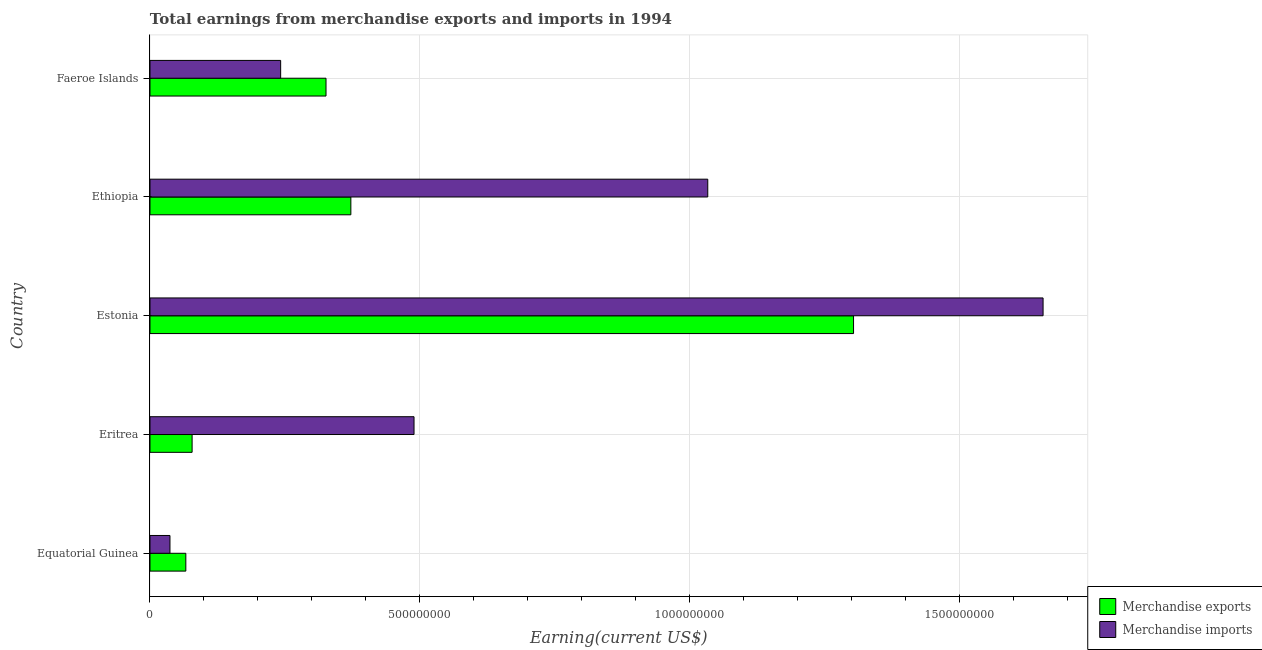How many different coloured bars are there?
Give a very brief answer. 2. How many groups of bars are there?
Your answer should be compact. 5. Are the number of bars per tick equal to the number of legend labels?
Your answer should be very brief. Yes. Are the number of bars on each tick of the Y-axis equal?
Ensure brevity in your answer.  Yes. How many bars are there on the 2nd tick from the top?
Give a very brief answer. 2. What is the label of the 4th group of bars from the top?
Keep it short and to the point. Eritrea. In how many cases, is the number of bars for a given country not equal to the number of legend labels?
Your answer should be compact. 0. What is the earnings from merchandise exports in Eritrea?
Keep it short and to the point. 7.80e+07. Across all countries, what is the maximum earnings from merchandise imports?
Offer a very short reply. 1.65e+09. Across all countries, what is the minimum earnings from merchandise imports?
Offer a very short reply. 3.70e+07. In which country was the earnings from merchandise exports maximum?
Your answer should be very brief. Estonia. In which country was the earnings from merchandise imports minimum?
Provide a short and direct response. Equatorial Guinea. What is the total earnings from merchandise imports in the graph?
Ensure brevity in your answer.  3.46e+09. What is the difference between the earnings from merchandise exports in Equatorial Guinea and that in Faeroe Islands?
Provide a short and direct response. -2.60e+08. What is the difference between the earnings from merchandise exports in Eritrea and the earnings from merchandise imports in Ethiopia?
Offer a terse response. -9.55e+08. What is the average earnings from merchandise exports per country?
Offer a very short reply. 4.29e+08. What is the difference between the earnings from merchandise exports and earnings from merchandise imports in Faeroe Islands?
Your answer should be very brief. 8.40e+07. In how many countries, is the earnings from merchandise imports greater than 1100000000 US$?
Keep it short and to the point. 1. What is the ratio of the earnings from merchandise imports in Estonia to that in Ethiopia?
Keep it short and to the point. 1.6. Is the difference between the earnings from merchandise exports in Estonia and Ethiopia greater than the difference between the earnings from merchandise imports in Estonia and Ethiopia?
Your response must be concise. Yes. What is the difference between the highest and the second highest earnings from merchandise imports?
Offer a very short reply. 6.21e+08. What is the difference between the highest and the lowest earnings from merchandise imports?
Ensure brevity in your answer.  1.62e+09. Is the sum of the earnings from merchandise exports in Eritrea and Ethiopia greater than the maximum earnings from merchandise imports across all countries?
Your answer should be very brief. No. What does the 2nd bar from the bottom in Eritrea represents?
Offer a terse response. Merchandise imports. Are all the bars in the graph horizontal?
Provide a short and direct response. Yes. Are the values on the major ticks of X-axis written in scientific E-notation?
Keep it short and to the point. No. Where does the legend appear in the graph?
Your answer should be compact. Bottom right. How are the legend labels stacked?
Your answer should be compact. Vertical. What is the title of the graph?
Your answer should be compact. Total earnings from merchandise exports and imports in 1994. What is the label or title of the X-axis?
Offer a very short reply. Earning(current US$). What is the label or title of the Y-axis?
Provide a succinct answer. Country. What is the Earning(current US$) of Merchandise exports in Equatorial Guinea?
Offer a very short reply. 6.64e+07. What is the Earning(current US$) in Merchandise imports in Equatorial Guinea?
Provide a short and direct response. 3.70e+07. What is the Earning(current US$) in Merchandise exports in Eritrea?
Your answer should be very brief. 7.80e+07. What is the Earning(current US$) of Merchandise imports in Eritrea?
Give a very brief answer. 4.89e+08. What is the Earning(current US$) of Merchandise exports in Estonia?
Give a very brief answer. 1.30e+09. What is the Earning(current US$) in Merchandise imports in Estonia?
Make the answer very short. 1.65e+09. What is the Earning(current US$) in Merchandise exports in Ethiopia?
Your answer should be very brief. 3.72e+08. What is the Earning(current US$) in Merchandise imports in Ethiopia?
Your answer should be compact. 1.03e+09. What is the Earning(current US$) of Merchandise exports in Faeroe Islands?
Offer a very short reply. 3.26e+08. What is the Earning(current US$) of Merchandise imports in Faeroe Islands?
Provide a short and direct response. 2.42e+08. Across all countries, what is the maximum Earning(current US$) of Merchandise exports?
Your response must be concise. 1.30e+09. Across all countries, what is the maximum Earning(current US$) in Merchandise imports?
Give a very brief answer. 1.65e+09. Across all countries, what is the minimum Earning(current US$) of Merchandise exports?
Keep it short and to the point. 6.64e+07. Across all countries, what is the minimum Earning(current US$) of Merchandise imports?
Ensure brevity in your answer.  3.70e+07. What is the total Earning(current US$) in Merchandise exports in the graph?
Offer a terse response. 2.15e+09. What is the total Earning(current US$) of Merchandise imports in the graph?
Ensure brevity in your answer.  3.46e+09. What is the difference between the Earning(current US$) of Merchandise exports in Equatorial Guinea and that in Eritrea?
Make the answer very short. -1.16e+07. What is the difference between the Earning(current US$) of Merchandise imports in Equatorial Guinea and that in Eritrea?
Keep it short and to the point. -4.52e+08. What is the difference between the Earning(current US$) of Merchandise exports in Equatorial Guinea and that in Estonia?
Offer a terse response. -1.24e+09. What is the difference between the Earning(current US$) in Merchandise imports in Equatorial Guinea and that in Estonia?
Your answer should be very brief. -1.62e+09. What is the difference between the Earning(current US$) in Merchandise exports in Equatorial Guinea and that in Ethiopia?
Make the answer very short. -3.06e+08. What is the difference between the Earning(current US$) in Merchandise imports in Equatorial Guinea and that in Ethiopia?
Provide a short and direct response. -9.96e+08. What is the difference between the Earning(current US$) of Merchandise exports in Equatorial Guinea and that in Faeroe Islands?
Provide a succinct answer. -2.60e+08. What is the difference between the Earning(current US$) in Merchandise imports in Equatorial Guinea and that in Faeroe Islands?
Offer a very short reply. -2.05e+08. What is the difference between the Earning(current US$) in Merchandise exports in Eritrea and that in Estonia?
Make the answer very short. -1.22e+09. What is the difference between the Earning(current US$) of Merchandise imports in Eritrea and that in Estonia?
Ensure brevity in your answer.  -1.16e+09. What is the difference between the Earning(current US$) in Merchandise exports in Eritrea and that in Ethiopia?
Make the answer very short. -2.94e+08. What is the difference between the Earning(current US$) of Merchandise imports in Eritrea and that in Ethiopia?
Your answer should be compact. -5.44e+08. What is the difference between the Earning(current US$) in Merchandise exports in Eritrea and that in Faeroe Islands?
Give a very brief answer. -2.48e+08. What is the difference between the Earning(current US$) in Merchandise imports in Eritrea and that in Faeroe Islands?
Give a very brief answer. 2.47e+08. What is the difference between the Earning(current US$) in Merchandise exports in Estonia and that in Ethiopia?
Provide a succinct answer. 9.31e+08. What is the difference between the Earning(current US$) of Merchandise imports in Estonia and that in Ethiopia?
Offer a very short reply. 6.21e+08. What is the difference between the Earning(current US$) of Merchandise exports in Estonia and that in Faeroe Islands?
Provide a succinct answer. 9.77e+08. What is the difference between the Earning(current US$) in Merchandise imports in Estonia and that in Faeroe Islands?
Ensure brevity in your answer.  1.41e+09. What is the difference between the Earning(current US$) of Merchandise exports in Ethiopia and that in Faeroe Islands?
Your response must be concise. 4.60e+07. What is the difference between the Earning(current US$) in Merchandise imports in Ethiopia and that in Faeroe Islands?
Keep it short and to the point. 7.91e+08. What is the difference between the Earning(current US$) of Merchandise exports in Equatorial Guinea and the Earning(current US$) of Merchandise imports in Eritrea?
Provide a succinct answer. -4.23e+08. What is the difference between the Earning(current US$) in Merchandise exports in Equatorial Guinea and the Earning(current US$) in Merchandise imports in Estonia?
Give a very brief answer. -1.59e+09. What is the difference between the Earning(current US$) of Merchandise exports in Equatorial Guinea and the Earning(current US$) of Merchandise imports in Ethiopia?
Your response must be concise. -9.67e+08. What is the difference between the Earning(current US$) in Merchandise exports in Equatorial Guinea and the Earning(current US$) in Merchandise imports in Faeroe Islands?
Offer a terse response. -1.76e+08. What is the difference between the Earning(current US$) in Merchandise exports in Eritrea and the Earning(current US$) in Merchandise imports in Estonia?
Provide a succinct answer. -1.58e+09. What is the difference between the Earning(current US$) of Merchandise exports in Eritrea and the Earning(current US$) of Merchandise imports in Ethiopia?
Provide a succinct answer. -9.55e+08. What is the difference between the Earning(current US$) in Merchandise exports in Eritrea and the Earning(current US$) in Merchandise imports in Faeroe Islands?
Ensure brevity in your answer.  -1.64e+08. What is the difference between the Earning(current US$) of Merchandise exports in Estonia and the Earning(current US$) of Merchandise imports in Ethiopia?
Ensure brevity in your answer.  2.70e+08. What is the difference between the Earning(current US$) of Merchandise exports in Estonia and the Earning(current US$) of Merchandise imports in Faeroe Islands?
Keep it short and to the point. 1.06e+09. What is the difference between the Earning(current US$) in Merchandise exports in Ethiopia and the Earning(current US$) in Merchandise imports in Faeroe Islands?
Your response must be concise. 1.30e+08. What is the average Earning(current US$) of Merchandise exports per country?
Give a very brief answer. 4.29e+08. What is the average Earning(current US$) of Merchandise imports per country?
Make the answer very short. 6.91e+08. What is the difference between the Earning(current US$) of Merchandise exports and Earning(current US$) of Merchandise imports in Equatorial Guinea?
Give a very brief answer. 2.94e+07. What is the difference between the Earning(current US$) of Merchandise exports and Earning(current US$) of Merchandise imports in Eritrea?
Provide a succinct answer. -4.11e+08. What is the difference between the Earning(current US$) in Merchandise exports and Earning(current US$) in Merchandise imports in Estonia?
Give a very brief answer. -3.51e+08. What is the difference between the Earning(current US$) in Merchandise exports and Earning(current US$) in Merchandise imports in Ethiopia?
Your answer should be very brief. -6.61e+08. What is the difference between the Earning(current US$) in Merchandise exports and Earning(current US$) in Merchandise imports in Faeroe Islands?
Offer a terse response. 8.40e+07. What is the ratio of the Earning(current US$) of Merchandise exports in Equatorial Guinea to that in Eritrea?
Provide a succinct answer. 0.85. What is the ratio of the Earning(current US$) of Merchandise imports in Equatorial Guinea to that in Eritrea?
Your answer should be compact. 0.08. What is the ratio of the Earning(current US$) in Merchandise exports in Equatorial Guinea to that in Estonia?
Your answer should be very brief. 0.05. What is the ratio of the Earning(current US$) of Merchandise imports in Equatorial Guinea to that in Estonia?
Offer a very short reply. 0.02. What is the ratio of the Earning(current US$) in Merchandise exports in Equatorial Guinea to that in Ethiopia?
Your answer should be very brief. 0.18. What is the ratio of the Earning(current US$) in Merchandise imports in Equatorial Guinea to that in Ethiopia?
Ensure brevity in your answer.  0.04. What is the ratio of the Earning(current US$) in Merchandise exports in Equatorial Guinea to that in Faeroe Islands?
Offer a very short reply. 0.2. What is the ratio of the Earning(current US$) of Merchandise imports in Equatorial Guinea to that in Faeroe Islands?
Your response must be concise. 0.15. What is the ratio of the Earning(current US$) in Merchandise exports in Eritrea to that in Estonia?
Give a very brief answer. 0.06. What is the ratio of the Earning(current US$) of Merchandise imports in Eritrea to that in Estonia?
Ensure brevity in your answer.  0.3. What is the ratio of the Earning(current US$) in Merchandise exports in Eritrea to that in Ethiopia?
Your answer should be very brief. 0.21. What is the ratio of the Earning(current US$) of Merchandise imports in Eritrea to that in Ethiopia?
Your response must be concise. 0.47. What is the ratio of the Earning(current US$) of Merchandise exports in Eritrea to that in Faeroe Islands?
Your response must be concise. 0.24. What is the ratio of the Earning(current US$) of Merchandise imports in Eritrea to that in Faeroe Islands?
Offer a terse response. 2.02. What is the ratio of the Earning(current US$) in Merchandise exports in Estonia to that in Ethiopia?
Your answer should be very brief. 3.5. What is the ratio of the Earning(current US$) in Merchandise imports in Estonia to that in Ethiopia?
Your answer should be compact. 1.6. What is the ratio of the Earning(current US$) of Merchandise exports in Estonia to that in Faeroe Islands?
Your response must be concise. 4. What is the ratio of the Earning(current US$) in Merchandise imports in Estonia to that in Faeroe Islands?
Provide a succinct answer. 6.83. What is the ratio of the Earning(current US$) of Merchandise exports in Ethiopia to that in Faeroe Islands?
Your answer should be very brief. 1.14. What is the ratio of the Earning(current US$) of Merchandise imports in Ethiopia to that in Faeroe Islands?
Make the answer very short. 4.27. What is the difference between the highest and the second highest Earning(current US$) of Merchandise exports?
Your answer should be very brief. 9.31e+08. What is the difference between the highest and the second highest Earning(current US$) of Merchandise imports?
Keep it short and to the point. 6.21e+08. What is the difference between the highest and the lowest Earning(current US$) of Merchandise exports?
Keep it short and to the point. 1.24e+09. What is the difference between the highest and the lowest Earning(current US$) of Merchandise imports?
Your response must be concise. 1.62e+09. 